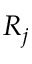Convert formula to latex. <formula><loc_0><loc_0><loc_500><loc_500>R _ { j }</formula> 